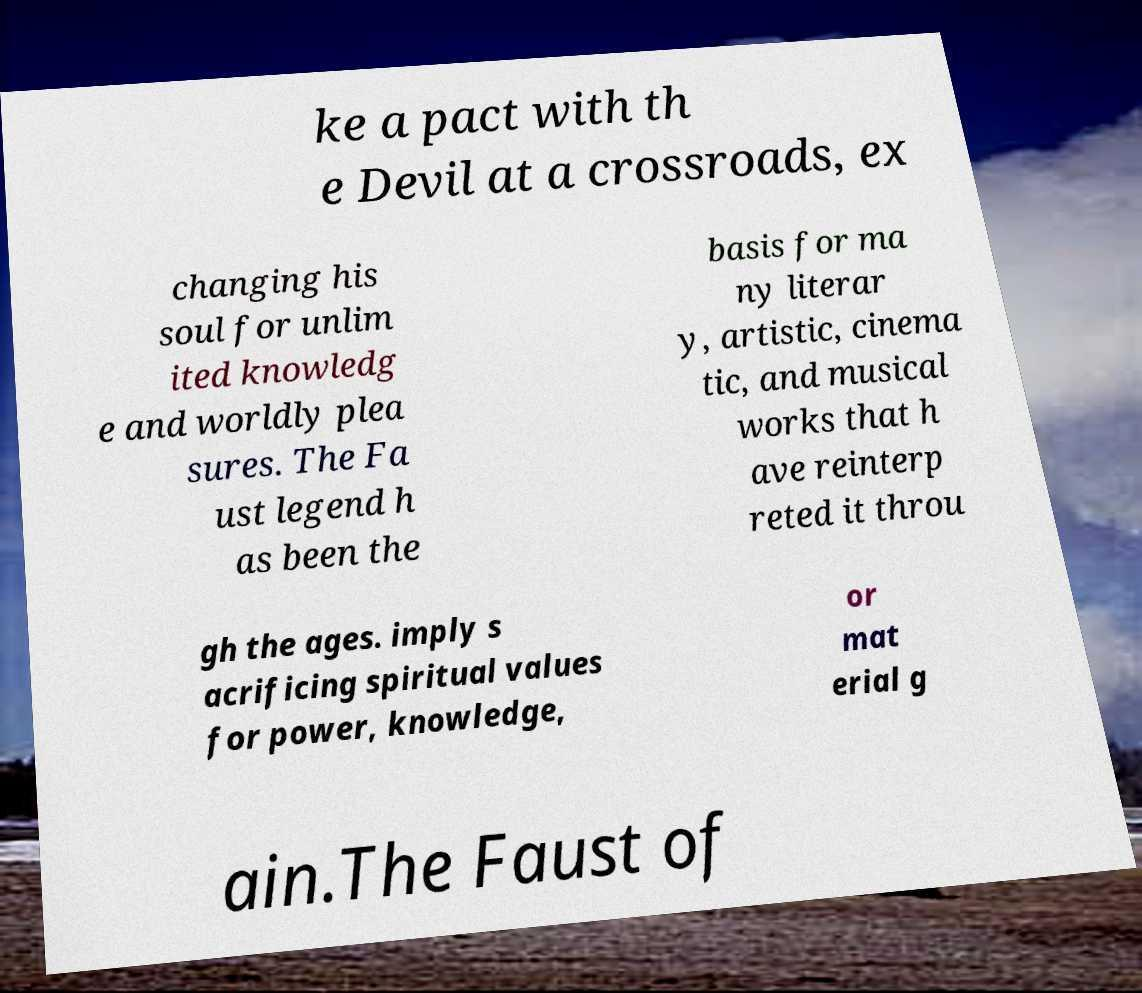Could you assist in decoding the text presented in this image and type it out clearly? ke a pact with th e Devil at a crossroads, ex changing his soul for unlim ited knowledg e and worldly plea sures. The Fa ust legend h as been the basis for ma ny literar y, artistic, cinema tic, and musical works that h ave reinterp reted it throu gh the ages. imply s acrificing spiritual values for power, knowledge, or mat erial g ain.The Faust of 